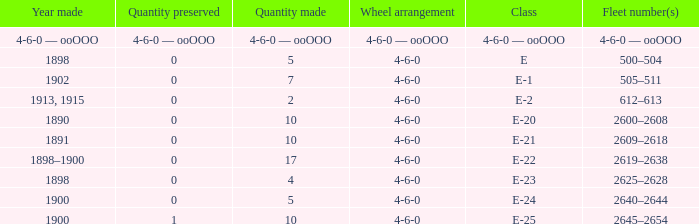What is the quantity preserved of the e-1 class? 0.0. 